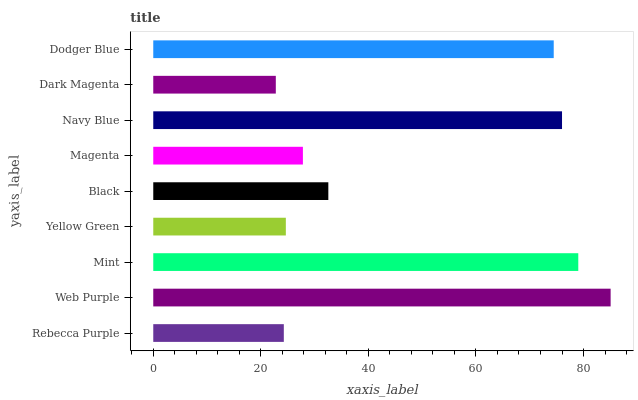Is Dark Magenta the minimum?
Answer yes or no. Yes. Is Web Purple the maximum?
Answer yes or no. Yes. Is Mint the minimum?
Answer yes or no. No. Is Mint the maximum?
Answer yes or no. No. Is Web Purple greater than Mint?
Answer yes or no. Yes. Is Mint less than Web Purple?
Answer yes or no. Yes. Is Mint greater than Web Purple?
Answer yes or no. No. Is Web Purple less than Mint?
Answer yes or no. No. Is Black the high median?
Answer yes or no. Yes. Is Black the low median?
Answer yes or no. Yes. Is Web Purple the high median?
Answer yes or no. No. Is Dodger Blue the low median?
Answer yes or no. No. 